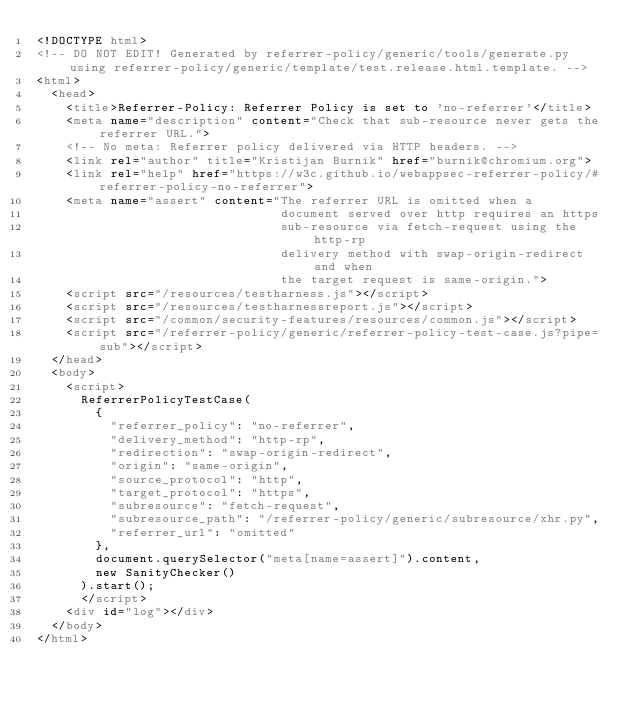Convert code to text. <code><loc_0><loc_0><loc_500><loc_500><_HTML_><!DOCTYPE html>
<!-- DO NOT EDIT! Generated by referrer-policy/generic/tools/generate.py using referrer-policy/generic/template/test.release.html.template. -->
<html>
  <head>
    <title>Referrer-Policy: Referrer Policy is set to 'no-referrer'</title>
    <meta name="description" content="Check that sub-resource never gets the referrer URL.">
    <!-- No meta: Referrer policy delivered via HTTP headers. -->
    <link rel="author" title="Kristijan Burnik" href="burnik@chromium.org">
    <link rel="help" href="https://w3c.github.io/webappsec-referrer-policy/#referrer-policy-no-referrer">
    <meta name="assert" content="The referrer URL is omitted when a
                                 document served over http requires an https
                                 sub-resource via fetch-request using the http-rp
                                 delivery method with swap-origin-redirect and when
                                 the target request is same-origin.">
    <script src="/resources/testharness.js"></script>
    <script src="/resources/testharnessreport.js"></script>
    <script src="/common/security-features/resources/common.js"></script>
    <script src="/referrer-policy/generic/referrer-policy-test-case.js?pipe=sub"></script>
  </head>
  <body>
    <script>
      ReferrerPolicyTestCase(
        {
          "referrer_policy": "no-referrer",
          "delivery_method": "http-rp",
          "redirection": "swap-origin-redirect",
          "origin": "same-origin",
          "source_protocol": "http",
          "target_protocol": "https",
          "subresource": "fetch-request",
          "subresource_path": "/referrer-policy/generic/subresource/xhr.py",
          "referrer_url": "omitted"
        },
        document.querySelector("meta[name=assert]").content,
        new SanityChecker()
      ).start();
      </script>
    <div id="log"></div>
  </body>
</html>
</code> 